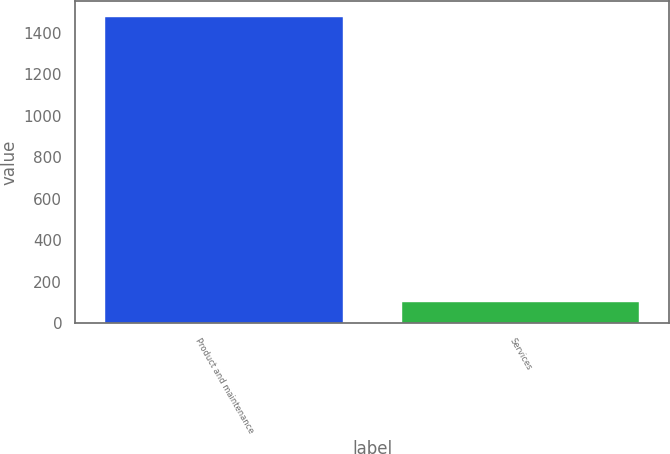Convert chart. <chart><loc_0><loc_0><loc_500><loc_500><bar_chart><fcel>Product and maintenance<fcel>Services<nl><fcel>1479.2<fcel>101.8<nl></chart> 